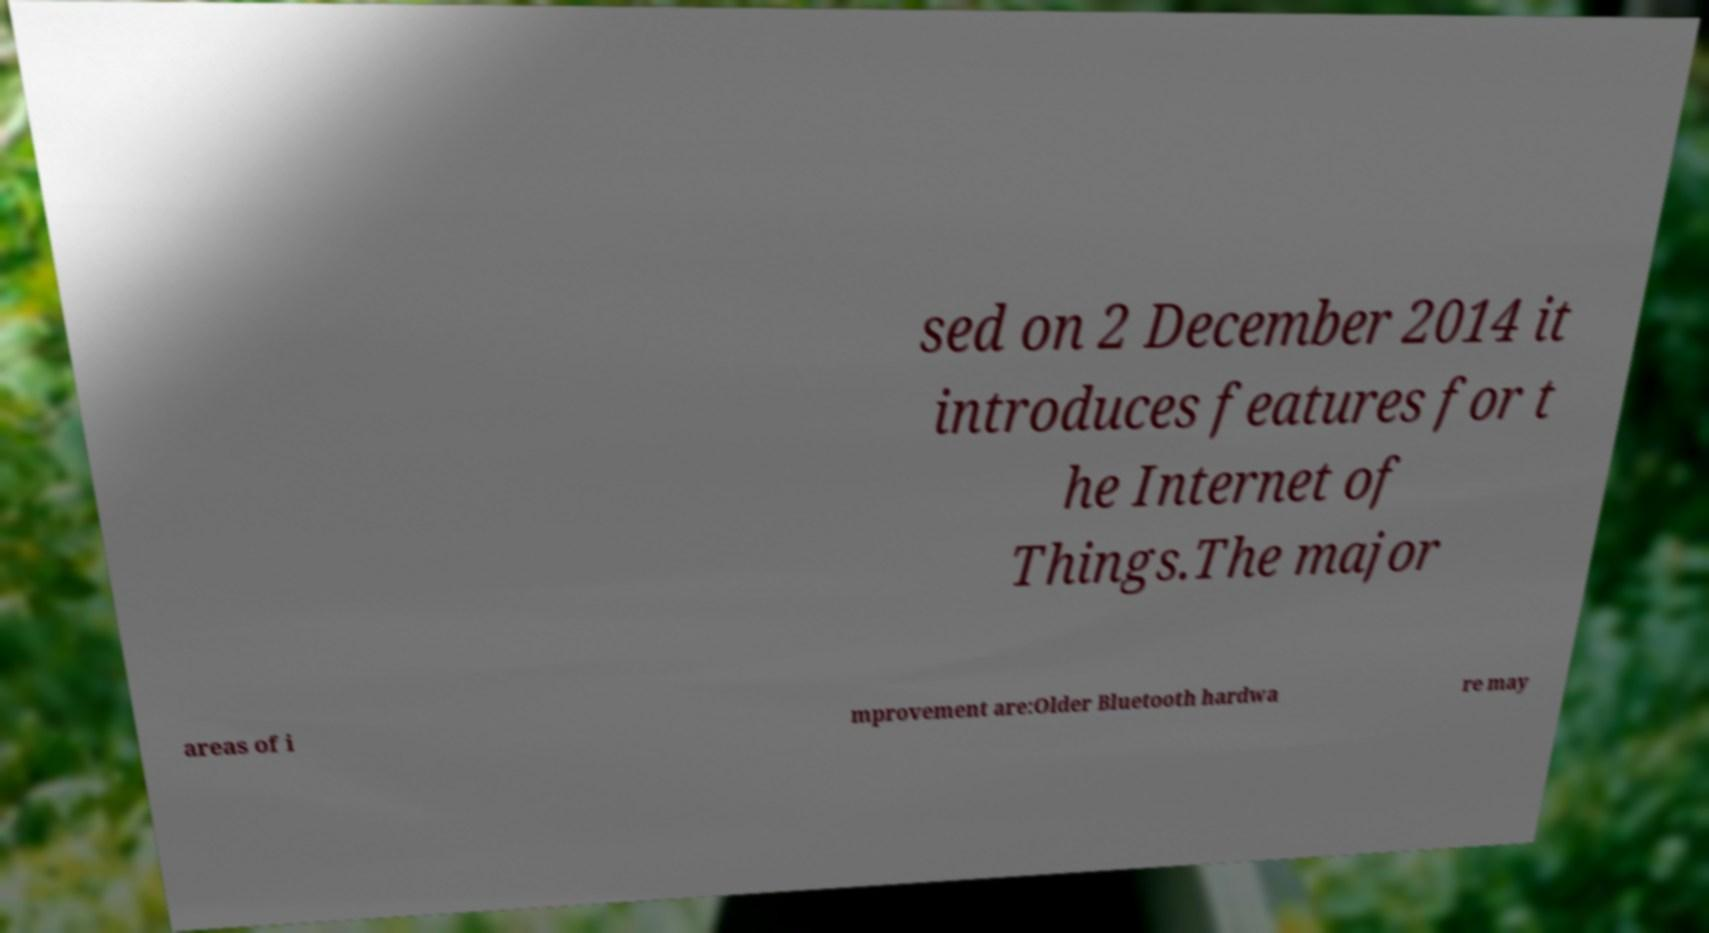Could you extract and type out the text from this image? sed on 2 December 2014 it introduces features for t he Internet of Things.The major areas of i mprovement are:Older Bluetooth hardwa re may 